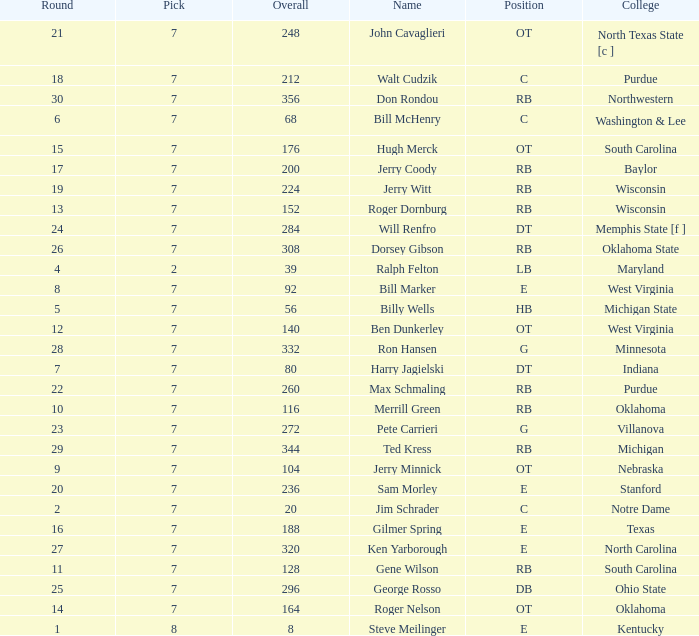What is the number of the round in which Ron Hansen was drafted and the overall is greater than 332? 0.0. 